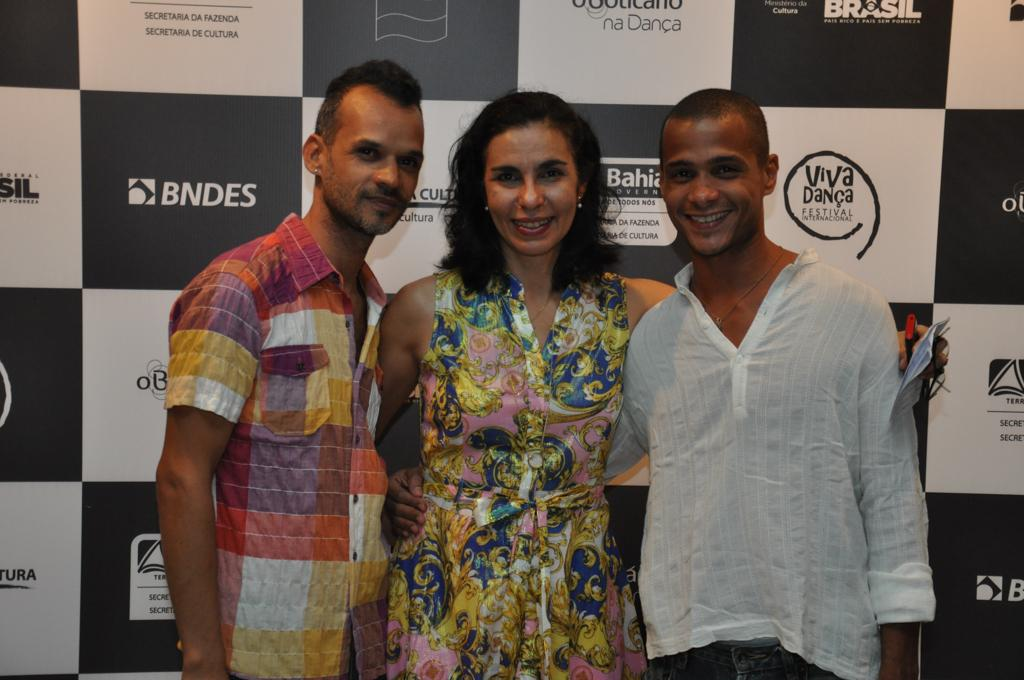What is the main subject of the image? There is a person standing in the center of the image. Where is the person standing? The person is standing on the floor. What can be seen in the background of the image? There is an advertisement visible in the background of the image. What type of bird is perched on the judge's shoulder in the image? There is no judge or bird present in the image; it only features a person standing on the floor with an advertisement visible in the background. 